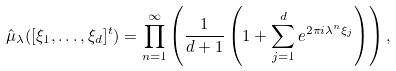Convert formula to latex. <formula><loc_0><loc_0><loc_500><loc_500>\hat { \mu } _ { \lambda } ( [ \xi _ { 1 } , \dots , \xi _ { d } ] ^ { t } ) = \prod _ { n = 1 } ^ { \infty } \left ( \frac { 1 } { d + 1 } \left ( 1 + \sum _ { j = 1 } ^ { d } e ^ { 2 \pi i \lambda ^ { n } \xi _ { j } } \right ) \right ) ,</formula> 